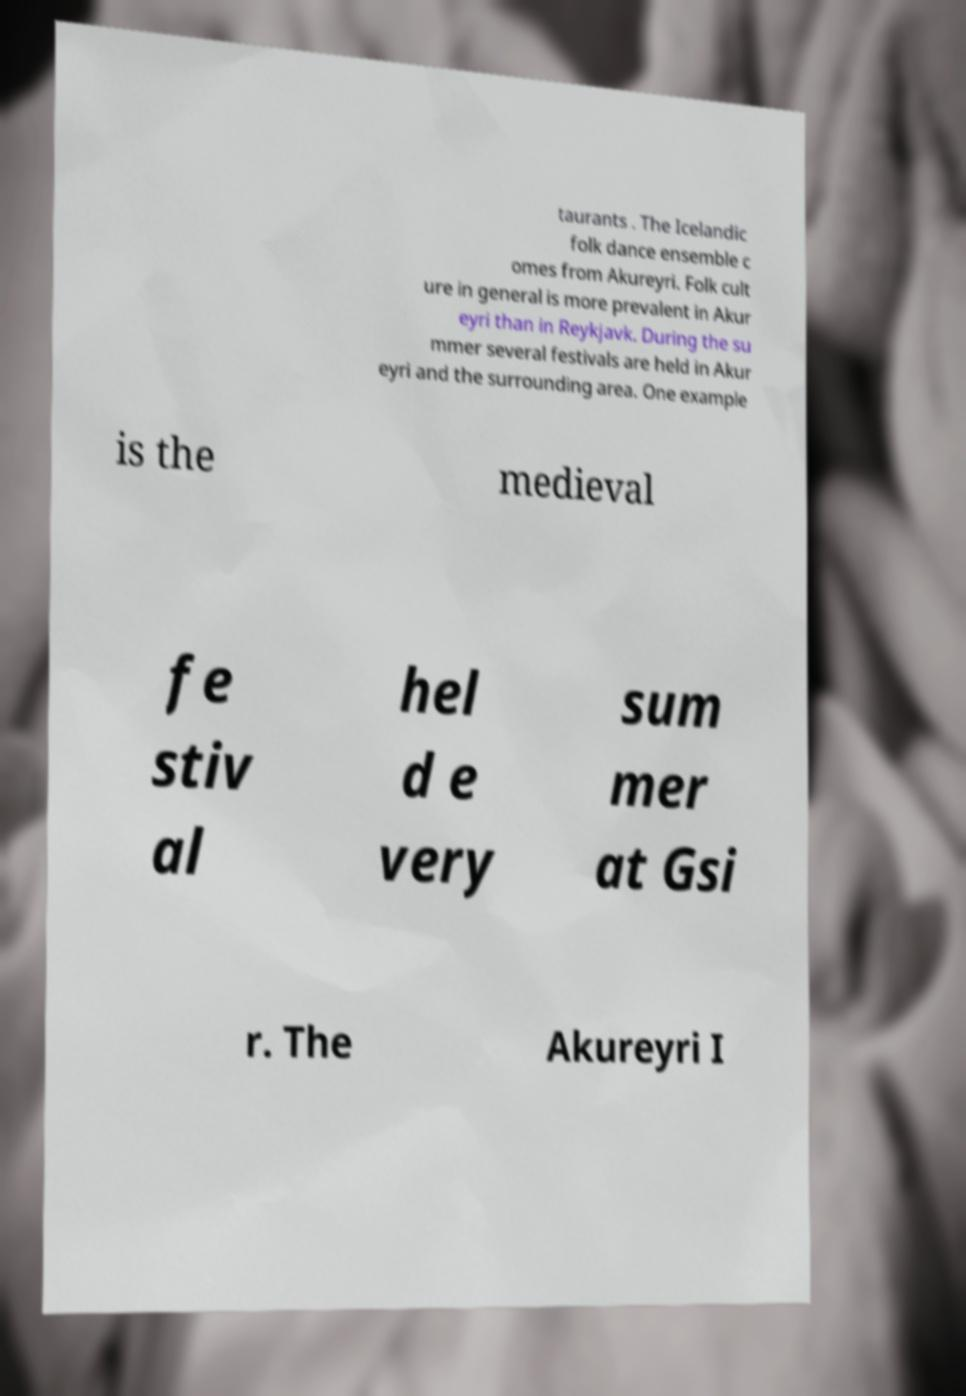There's text embedded in this image that I need extracted. Can you transcribe it verbatim? taurants . The Icelandic folk dance ensemble c omes from Akureyri. Folk cult ure in general is more prevalent in Akur eyri than in Reykjavk. During the su mmer several festivals are held in Akur eyri and the surrounding area. One example is the medieval fe stiv al hel d e very sum mer at Gsi r. The Akureyri I 